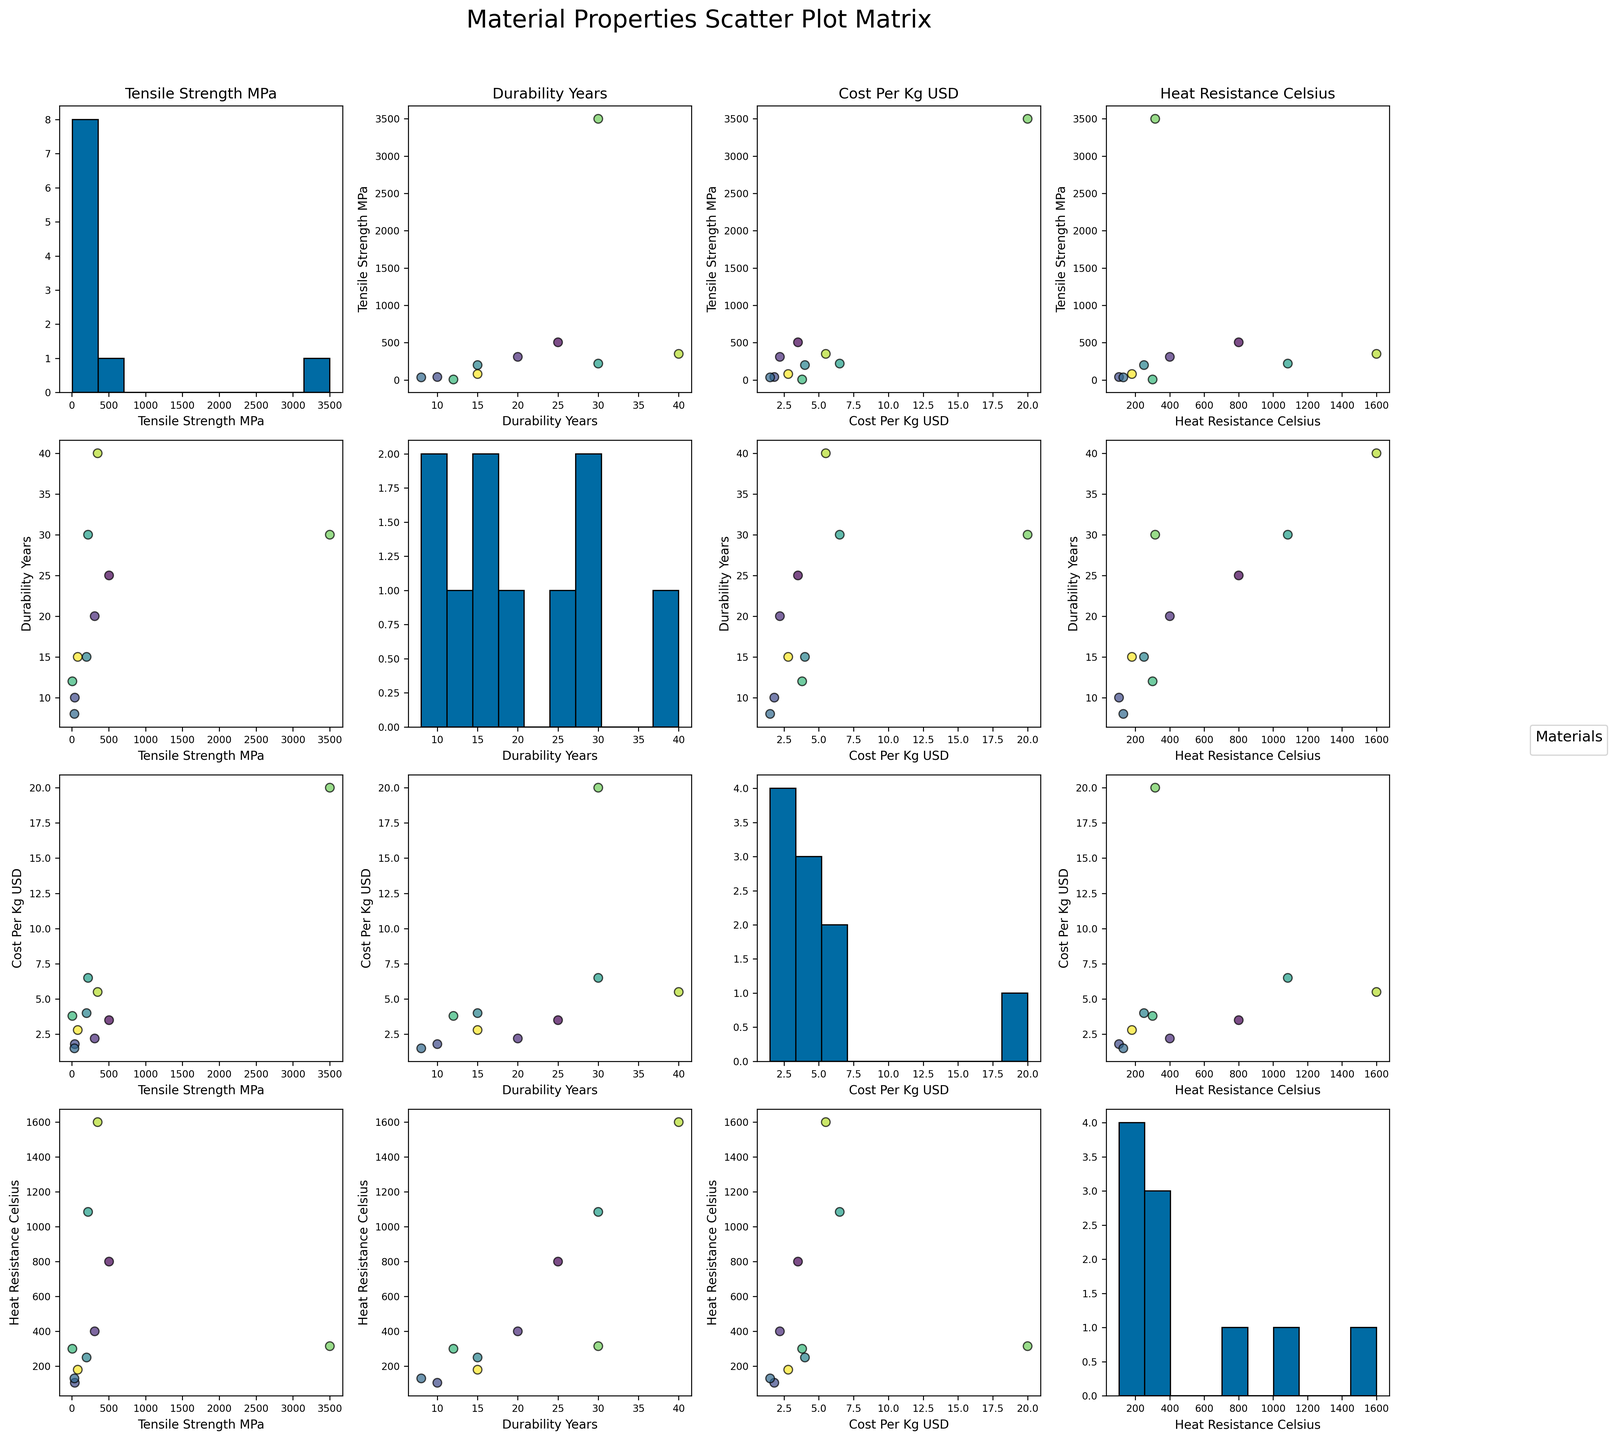What is the range of cost per kilogram for the materials? The minimum cost per kilogram is $1.50 (Polypropylene), and the maximum is $20.00 (Carbon Fiber). The range is calculated by subtracting the minimum value from the maximum value: $20.00 - $1.50 = $18.50.
Answer: $18.50 Which material has the highest tensile strength? By inspecting the scatter plots and histograms for tensile strength, it is evident that Carbon Fiber has the highest tensile strength at 3500 MPa.
Answer: Carbon Fiber What is the relationship between cost per kilogram and tensile strength? By examining the scatter plot of Cost_Per_Kg_USD vs. Tensile_Strength_MPa, there seems to be a positive correlation; materials with higher tensile strength generally have higher costs per kilogram.
Answer: Positive correlation Which material offers the best balance between durability and heat resistance? Evaluating the scatter plot of Durability_Years vs. Heat_Resistance_Celsius, Ceramic stands out with high values in both categories—40 years for durability and 1600°C for heat resistance.
Answer: Ceramic Are there any outliers in the heat resistance data? By looking at the histogram and scatter plots involving Heat_Resistance_Celsius, Carbon Fiber (315°C) and Copper (1085°C) seem to be outliers compared to the majority that cluster below these values.
Answer: Yes Which material is the most cost-effective given its durability and tensile strength? Considering both durability and tensile strength in relation to cost, Stainless Steel offers a good balance with 25 years durability, 505 MPa tensile strength, and a moderate cost of $3.50 per kg.
Answer: Stainless Steel How do Silicone Rubber's properties compare to ABS Plastic in terms of cost and durability? From the scatter plots of Cost_Per_Kg_USD vs. Durability_Years, Silicone Rubber costs more ($3.80/kg) than ABS Plastic ($1.80/kg) but has slightly better durability (12 years vs. 10 years).
Answer: Silicone Rubber costs more and is slightly more durable Which material has the lowest tensile strength? The histograms and scatter plots show that Silicone Rubber has the lowest tensile strength at 7 MPa.
Answer: Silicone Rubber Is there any material that combines high durability and low cost? Observing the scatter plot of Cost_Per_Kg_USD vs. Durability_Years, Nylon stands out with 15 years of durability at a relatively low cost of $2.80/kg.
Answer: Nylon How do Aluminum and Polypropylene compare in terms of heat resistance and tensile strength? From the scatter plots, Aluminum has higher tensile strength (310 MPa) and greater heat resistance (400 °C) compared to Polypropylene, which has a tensile strength of 35 MPa and heat resistance of 130 °C.
Answer: Aluminum has higher tensile strength and heat resistance 